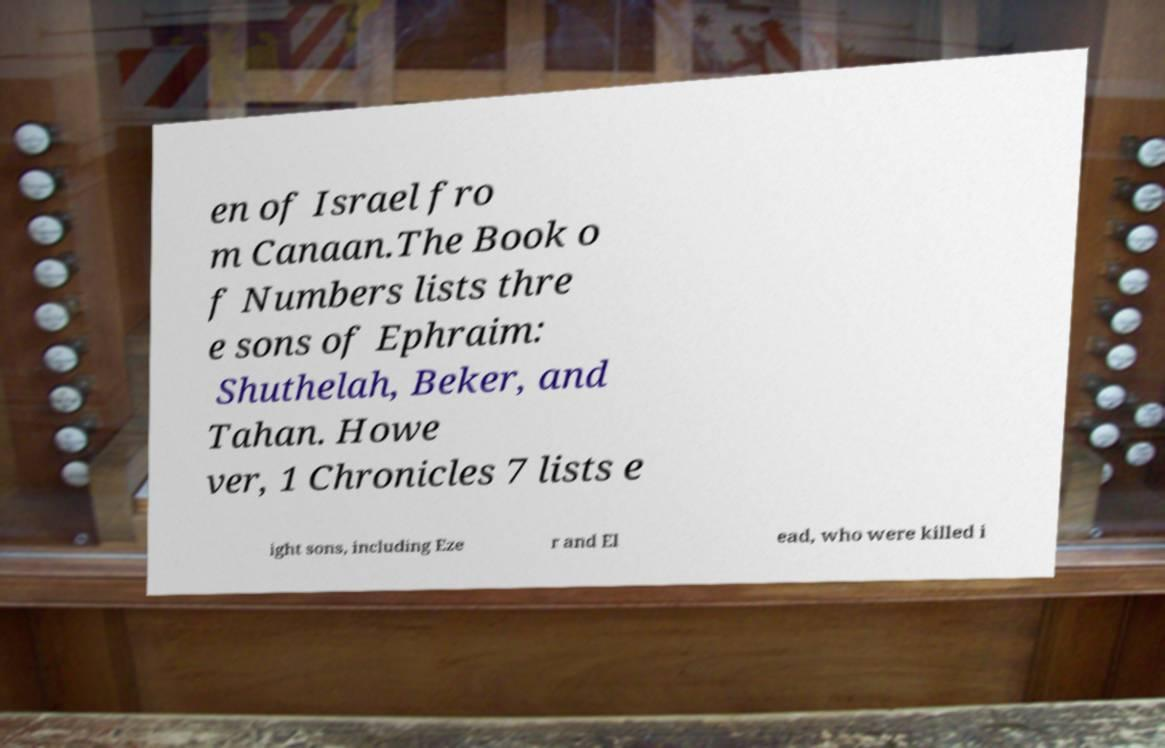For documentation purposes, I need the text within this image transcribed. Could you provide that? en of Israel fro m Canaan.The Book o f Numbers lists thre e sons of Ephraim: Shuthelah, Beker, and Tahan. Howe ver, 1 Chronicles 7 lists e ight sons, including Eze r and El ead, who were killed i 